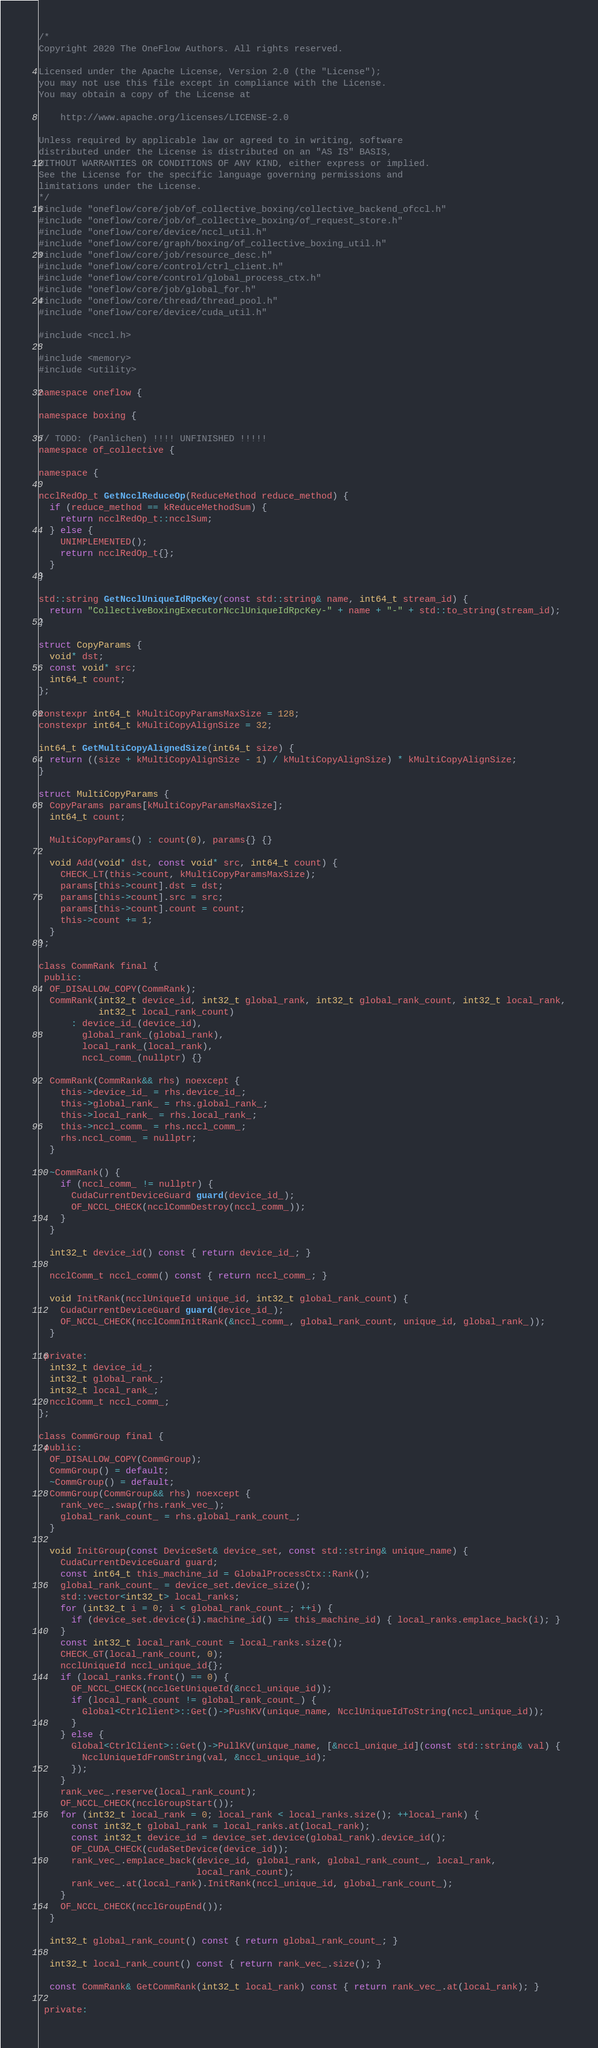<code> <loc_0><loc_0><loc_500><loc_500><_Cuda_>/*
Copyright 2020 The OneFlow Authors. All rights reserved.

Licensed under the Apache License, Version 2.0 (the "License");
you may not use this file except in compliance with the License.
You may obtain a copy of the License at

    http://www.apache.org/licenses/LICENSE-2.0

Unless required by applicable law or agreed to in writing, software
distributed under the License is distributed on an "AS IS" BASIS,
WITHOUT WARRANTIES OR CONDITIONS OF ANY KIND, either express or implied.
See the License for the specific language governing permissions and
limitations under the License.
*/
#include "oneflow/core/job/of_collective_boxing/collective_backend_ofccl.h"
#include "oneflow/core/job/of_collective_boxing/of_request_store.h"
#include "oneflow/core/device/nccl_util.h"
#include "oneflow/core/graph/boxing/of_collective_boxing_util.h"
#include "oneflow/core/job/resource_desc.h"
#include "oneflow/core/control/ctrl_client.h"
#include "oneflow/core/control/global_process_ctx.h"
#include "oneflow/core/job/global_for.h"
#include "oneflow/core/thread/thread_pool.h"
#include "oneflow/core/device/cuda_util.h"

#include <nccl.h>

#include <memory>
#include <utility>

namespace oneflow {

namespace boxing {

// TODO: (Panlichen) !!!! UNFINISHED !!!!!
namespace of_collective {

namespace {

ncclRedOp_t GetNcclReduceOp(ReduceMethod reduce_method) {
  if (reduce_method == kReduceMethodSum) {
    return ncclRedOp_t::ncclSum;
  } else {
    UNIMPLEMENTED();
    return ncclRedOp_t{};
  }
}

std::string GetNcclUniqueIdRpcKey(const std::string& name, int64_t stream_id) {
  return "CollectiveBoxingExecutorNcclUniqueIdRpcKey-" + name + "-" + std::to_string(stream_id);
}

struct CopyParams {
  void* dst;
  const void* src;
  int64_t count;
};

constexpr int64_t kMultiCopyParamsMaxSize = 128;
constexpr int64_t kMultiCopyAlignSize = 32;

int64_t GetMultiCopyAlignedSize(int64_t size) {
  return ((size + kMultiCopyAlignSize - 1) / kMultiCopyAlignSize) * kMultiCopyAlignSize;
}

struct MultiCopyParams {
  CopyParams params[kMultiCopyParamsMaxSize];
  int64_t count;

  MultiCopyParams() : count(0), params{} {}

  void Add(void* dst, const void* src, int64_t count) {
    CHECK_LT(this->count, kMultiCopyParamsMaxSize);
    params[this->count].dst = dst;
    params[this->count].src = src;
    params[this->count].count = count;
    this->count += 1;
  }
};

class CommRank final {
 public:
  OF_DISALLOW_COPY(CommRank);
  CommRank(int32_t device_id, int32_t global_rank, int32_t global_rank_count, int32_t local_rank,
           int32_t local_rank_count)
      : device_id_(device_id),
        global_rank_(global_rank),
        local_rank_(local_rank),
        nccl_comm_(nullptr) {}

  CommRank(CommRank&& rhs) noexcept {
    this->device_id_ = rhs.device_id_;
    this->global_rank_ = rhs.global_rank_;
    this->local_rank_ = rhs.local_rank_;
    this->nccl_comm_ = rhs.nccl_comm_;
    rhs.nccl_comm_ = nullptr;
  }

  ~CommRank() {
    if (nccl_comm_ != nullptr) {
      CudaCurrentDeviceGuard guard(device_id_);
      OF_NCCL_CHECK(ncclCommDestroy(nccl_comm_));
    }
  }

  int32_t device_id() const { return device_id_; }

  ncclComm_t nccl_comm() const { return nccl_comm_; }

  void InitRank(ncclUniqueId unique_id, int32_t global_rank_count) {
    CudaCurrentDeviceGuard guard(device_id_);
    OF_NCCL_CHECK(ncclCommInitRank(&nccl_comm_, global_rank_count, unique_id, global_rank_));
  }

 private:
  int32_t device_id_;
  int32_t global_rank_;
  int32_t local_rank_;
  ncclComm_t nccl_comm_;
};

class CommGroup final {
 public:
  OF_DISALLOW_COPY(CommGroup);
  CommGroup() = default;
  ~CommGroup() = default;
  CommGroup(CommGroup&& rhs) noexcept {
    rank_vec_.swap(rhs.rank_vec_);
    global_rank_count_ = rhs.global_rank_count_;
  }

  void InitGroup(const DeviceSet& device_set, const std::string& unique_name) {
    CudaCurrentDeviceGuard guard;
    const int64_t this_machine_id = GlobalProcessCtx::Rank();
    global_rank_count_ = device_set.device_size();
    std::vector<int32_t> local_ranks;
    for (int32_t i = 0; i < global_rank_count_; ++i) {
      if (device_set.device(i).machine_id() == this_machine_id) { local_ranks.emplace_back(i); }
    }
    const int32_t local_rank_count = local_ranks.size();
    CHECK_GT(local_rank_count, 0);
    ncclUniqueId nccl_unique_id{};
    if (local_ranks.front() == 0) {
      OF_NCCL_CHECK(ncclGetUniqueId(&nccl_unique_id));
      if (local_rank_count != global_rank_count_) {
        Global<CtrlClient>::Get()->PushKV(unique_name, NcclUniqueIdToString(nccl_unique_id));
      }
    } else {
      Global<CtrlClient>::Get()->PullKV(unique_name, [&nccl_unique_id](const std::string& val) {
        NcclUniqueIdFromString(val, &nccl_unique_id);
      });
    }
    rank_vec_.reserve(local_rank_count);
    OF_NCCL_CHECK(ncclGroupStart());
    for (int32_t local_rank = 0; local_rank < local_ranks.size(); ++local_rank) {
      const int32_t global_rank = local_ranks.at(local_rank);
      const int32_t device_id = device_set.device(global_rank).device_id();
      OF_CUDA_CHECK(cudaSetDevice(device_id));
      rank_vec_.emplace_back(device_id, global_rank, global_rank_count_, local_rank,
                             local_rank_count);
      rank_vec_.at(local_rank).InitRank(nccl_unique_id, global_rank_count_);
    }
    OF_NCCL_CHECK(ncclGroupEnd());
  }

  int32_t global_rank_count() const { return global_rank_count_; }

  int32_t local_rank_count() const { return rank_vec_.size(); }

  const CommRank& GetCommRank(int32_t local_rank) const { return rank_vec_.at(local_rank); }

 private:</code> 